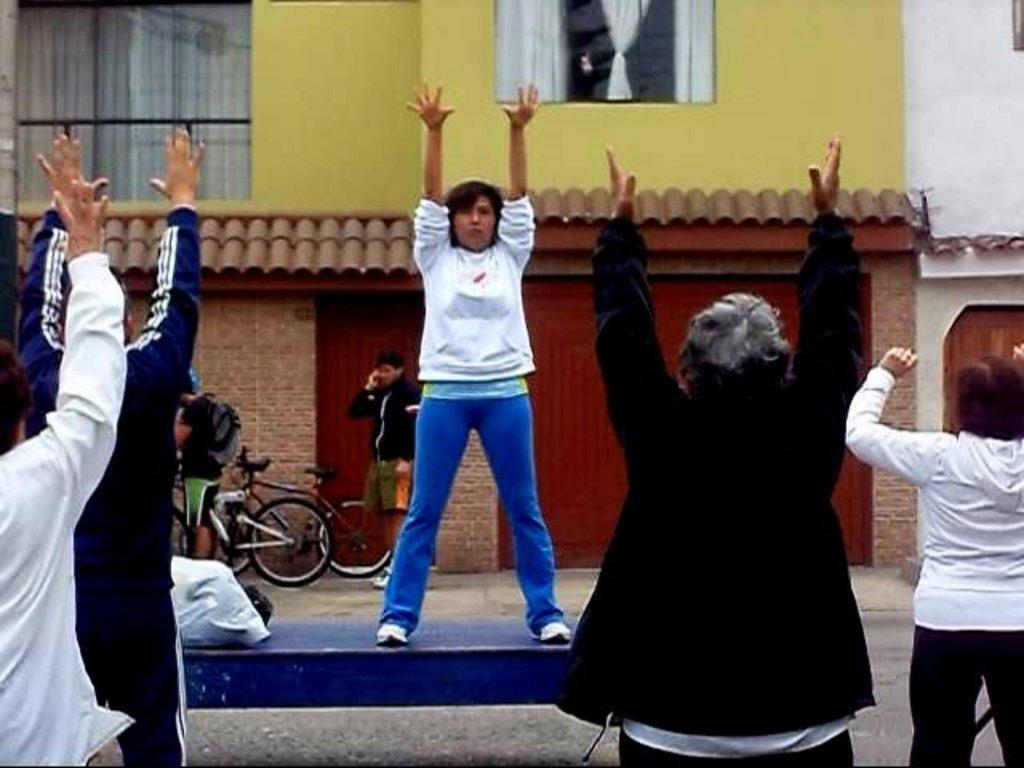What type of structures can be seen in the image? There are buildings in the image. Can you describe a specific feature of the buildings? There is a window in the image. What is associated with the window? There are curtains associated with the window. Who or what can be seen in the image? There are people visible in the image. What mode of transportation can be seen in the image? There are bicycles in the image. What color is the shirt worn by the yam in the image? There is no yam or shirt present in the image. 